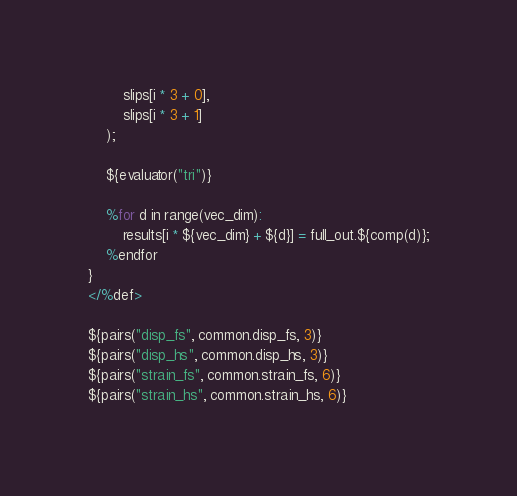<code> <loc_0><loc_0><loc_500><loc_500><_Cuda_>        slips[i * 3 + 0],
        slips[i * 3 + 1]
    );

    ${evaluator("tri")}

    %for d in range(vec_dim):
        results[i * ${vec_dim} + ${d}] = full_out.${comp(d)};
    %endfor
}
</%def>

${pairs("disp_fs", common.disp_fs, 3)}
${pairs("disp_hs", common.disp_hs, 3)}
${pairs("strain_fs", common.strain_fs, 6)}
${pairs("strain_hs", common.strain_hs, 6)}
</code> 